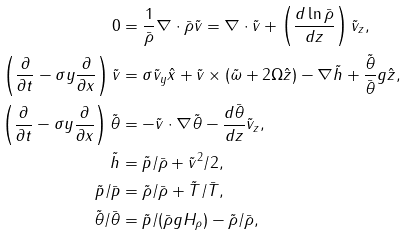<formula> <loc_0><loc_0><loc_500><loc_500>0 & = \frac { 1 } { \bar { \rho } } \nabla \cdot \bar { \rho } \tilde { v } = \nabla \cdot \tilde { v } + \left ( \frac { d \ln \bar { \rho } } { d z } \right ) \tilde { v } _ { z } , \\ \left ( \frac { \partial } { \partial t } - \sigma y \frac { \partial } { \partial x } \right ) \tilde { v } & = \sigma \tilde { v } _ { y } \hat { x } + \tilde { v } \times ( \tilde { \omega } + 2 \Omega \hat { z } ) - \nabla \tilde { h } + \frac { \tilde { \theta } } { \bar { \theta } } g \hat { z } , \\ \left ( \frac { \partial } { \partial t } - \sigma y \frac { \partial } { \partial x } \right ) \tilde { \theta } & = - \tilde { v } \cdot \nabla \tilde { \theta } - \frac { d \bar { \theta } } { d z } \tilde { v } _ { z } , \\ \tilde { h } & = \tilde { p } / \bar { \rho } + \tilde { v } ^ { 2 } / 2 , \\ \tilde { p } / \bar { p } & = \tilde { \rho } / \bar { \rho } + \tilde { T } / \bar { T } , \\ \tilde { \theta } / \bar { \theta } & = \tilde { p } / ( \bar { \rho } g H _ { \rho } ) - \tilde { \rho } / \bar { \rho } ,</formula> 